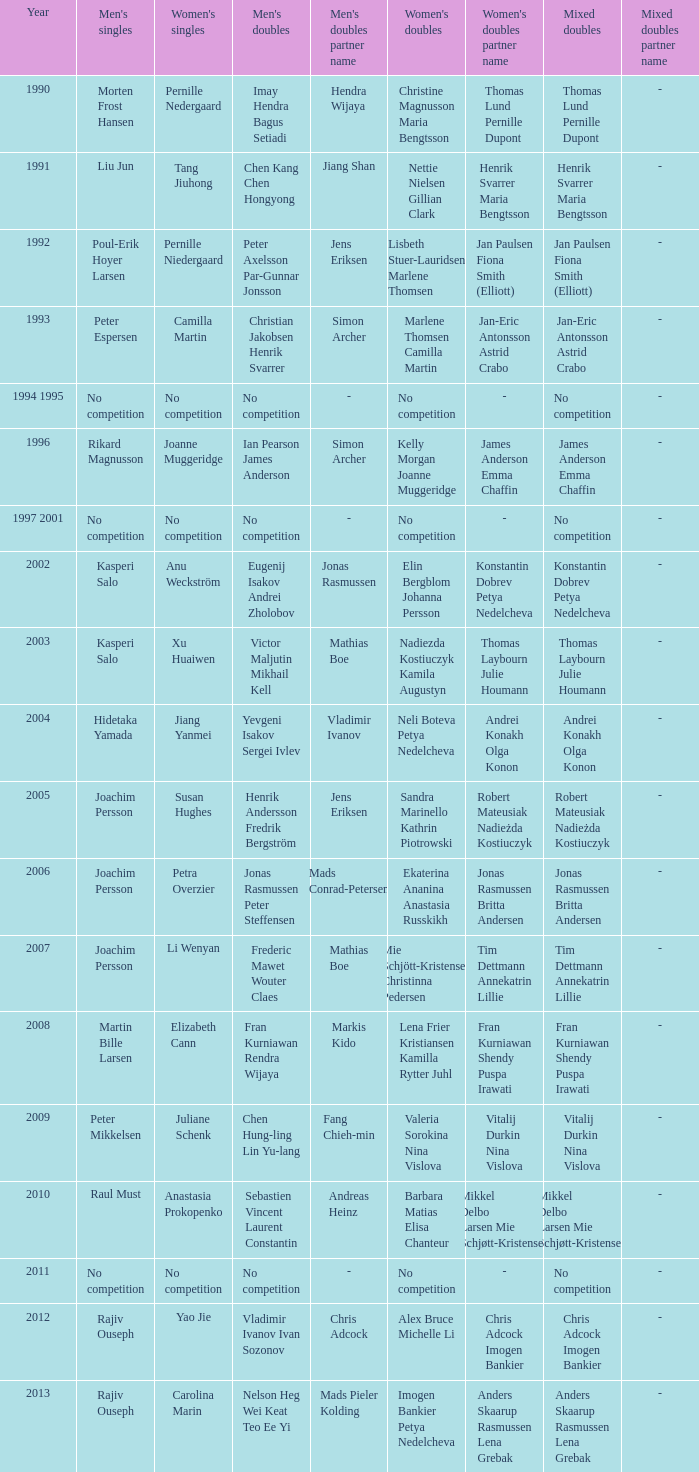What year did Carolina Marin win the Women's singles? 2013.0. 